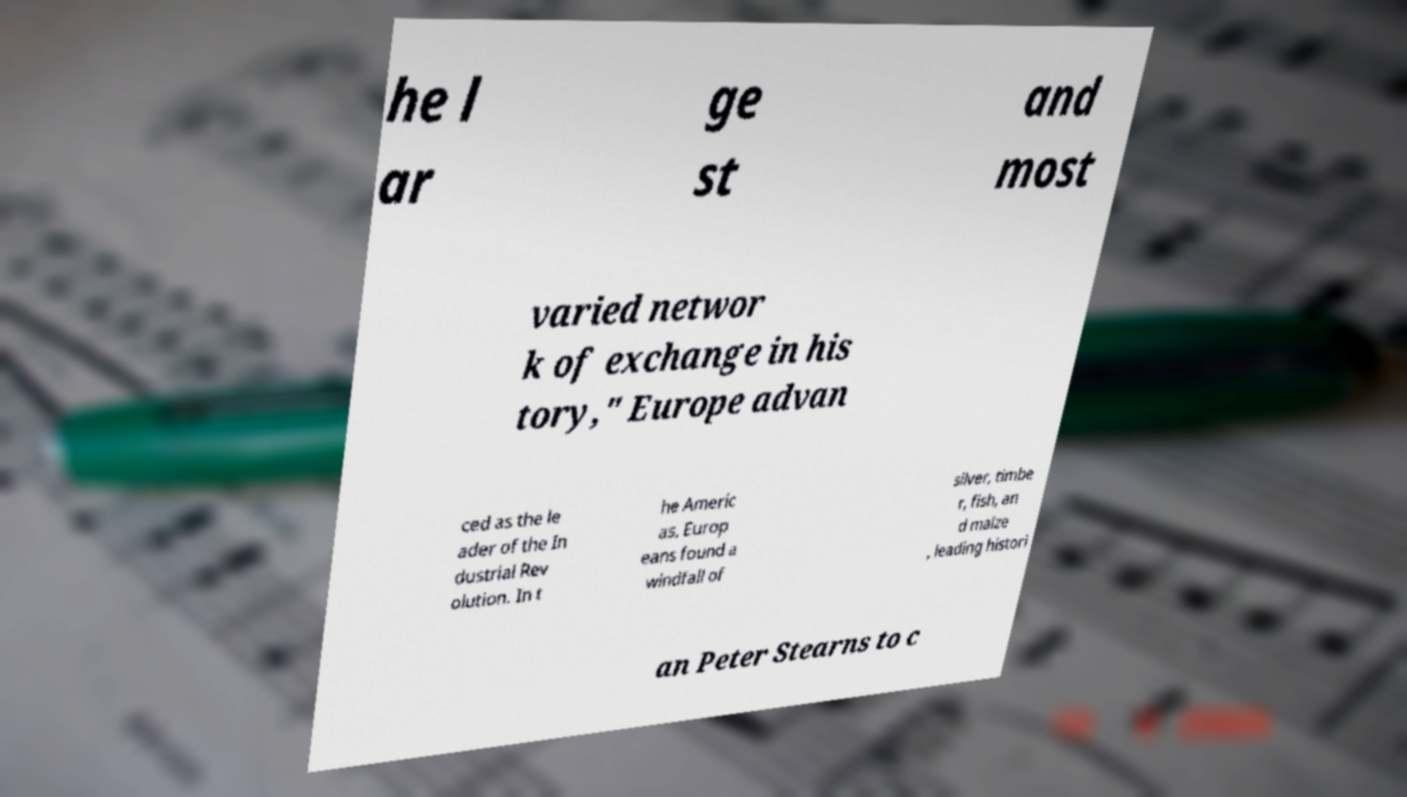Could you assist in decoding the text presented in this image and type it out clearly? he l ar ge st and most varied networ k of exchange in his tory," Europe advan ced as the le ader of the In dustrial Rev olution. In t he Americ as, Europ eans found a windfall of silver, timbe r, fish, an d maize , leading histori an Peter Stearns to c 